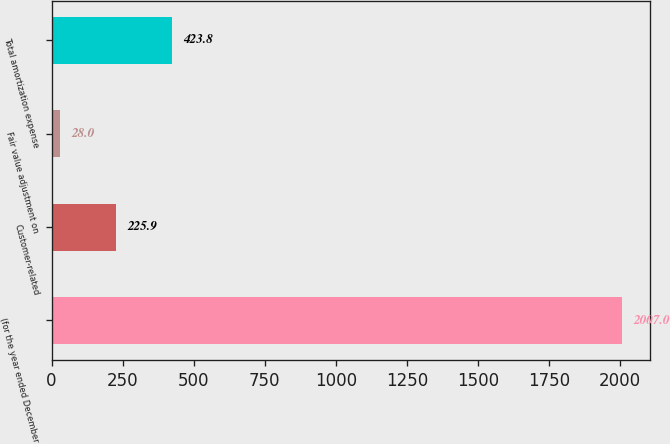<chart> <loc_0><loc_0><loc_500><loc_500><bar_chart><fcel>(for the year ended December<fcel>Customer-related<fcel>Fair value adjustment on<fcel>Total amortization expense<nl><fcel>2007<fcel>225.9<fcel>28<fcel>423.8<nl></chart> 